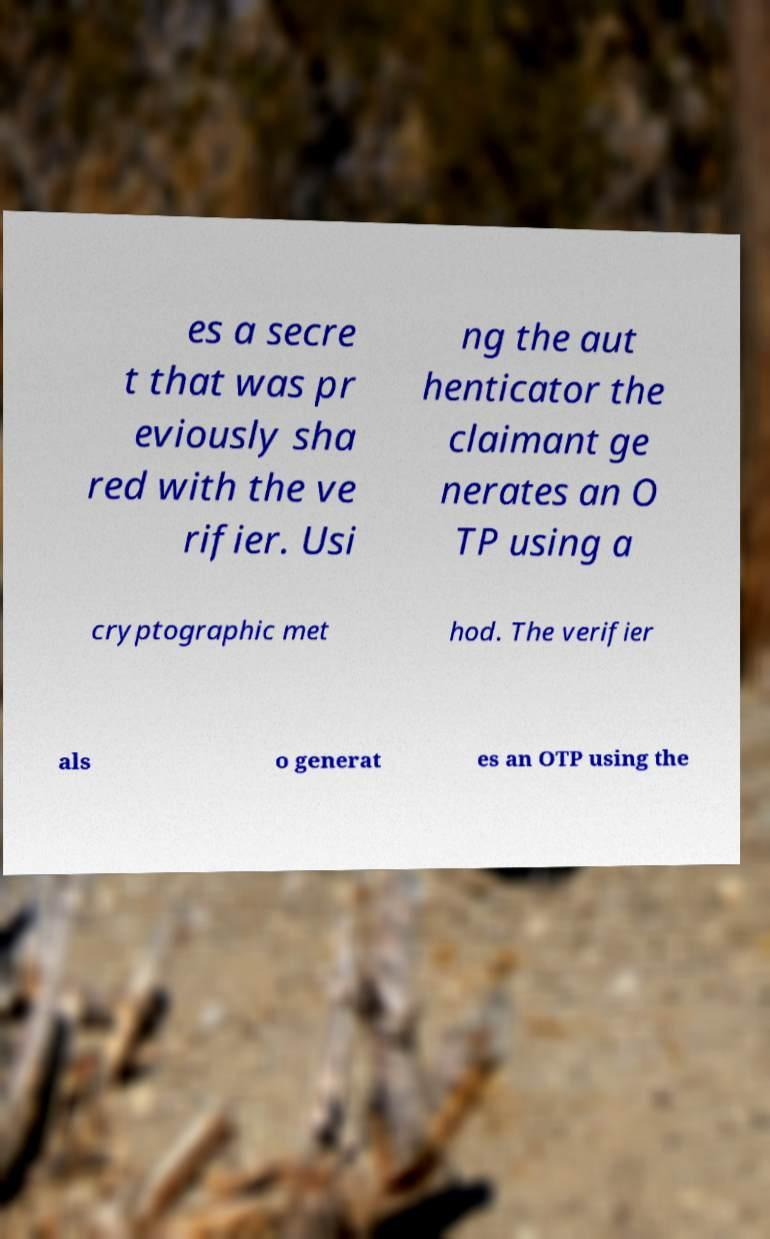Can you accurately transcribe the text from the provided image for me? es a secre t that was pr eviously sha red with the ve rifier. Usi ng the aut henticator the claimant ge nerates an O TP using a cryptographic met hod. The verifier als o generat es an OTP using the 